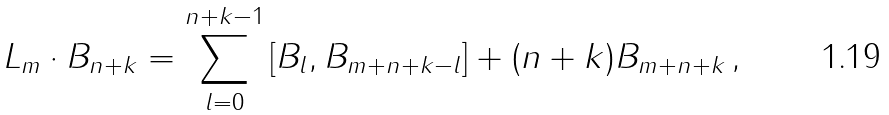<formula> <loc_0><loc_0><loc_500><loc_500>L _ { m } \cdot B _ { n + k } = \sum _ { l = 0 } ^ { n + k - 1 } \left [ B _ { l } , B _ { m + n + k - l } \right ] + ( n + k ) B _ { m + n + k } \, ,</formula> 